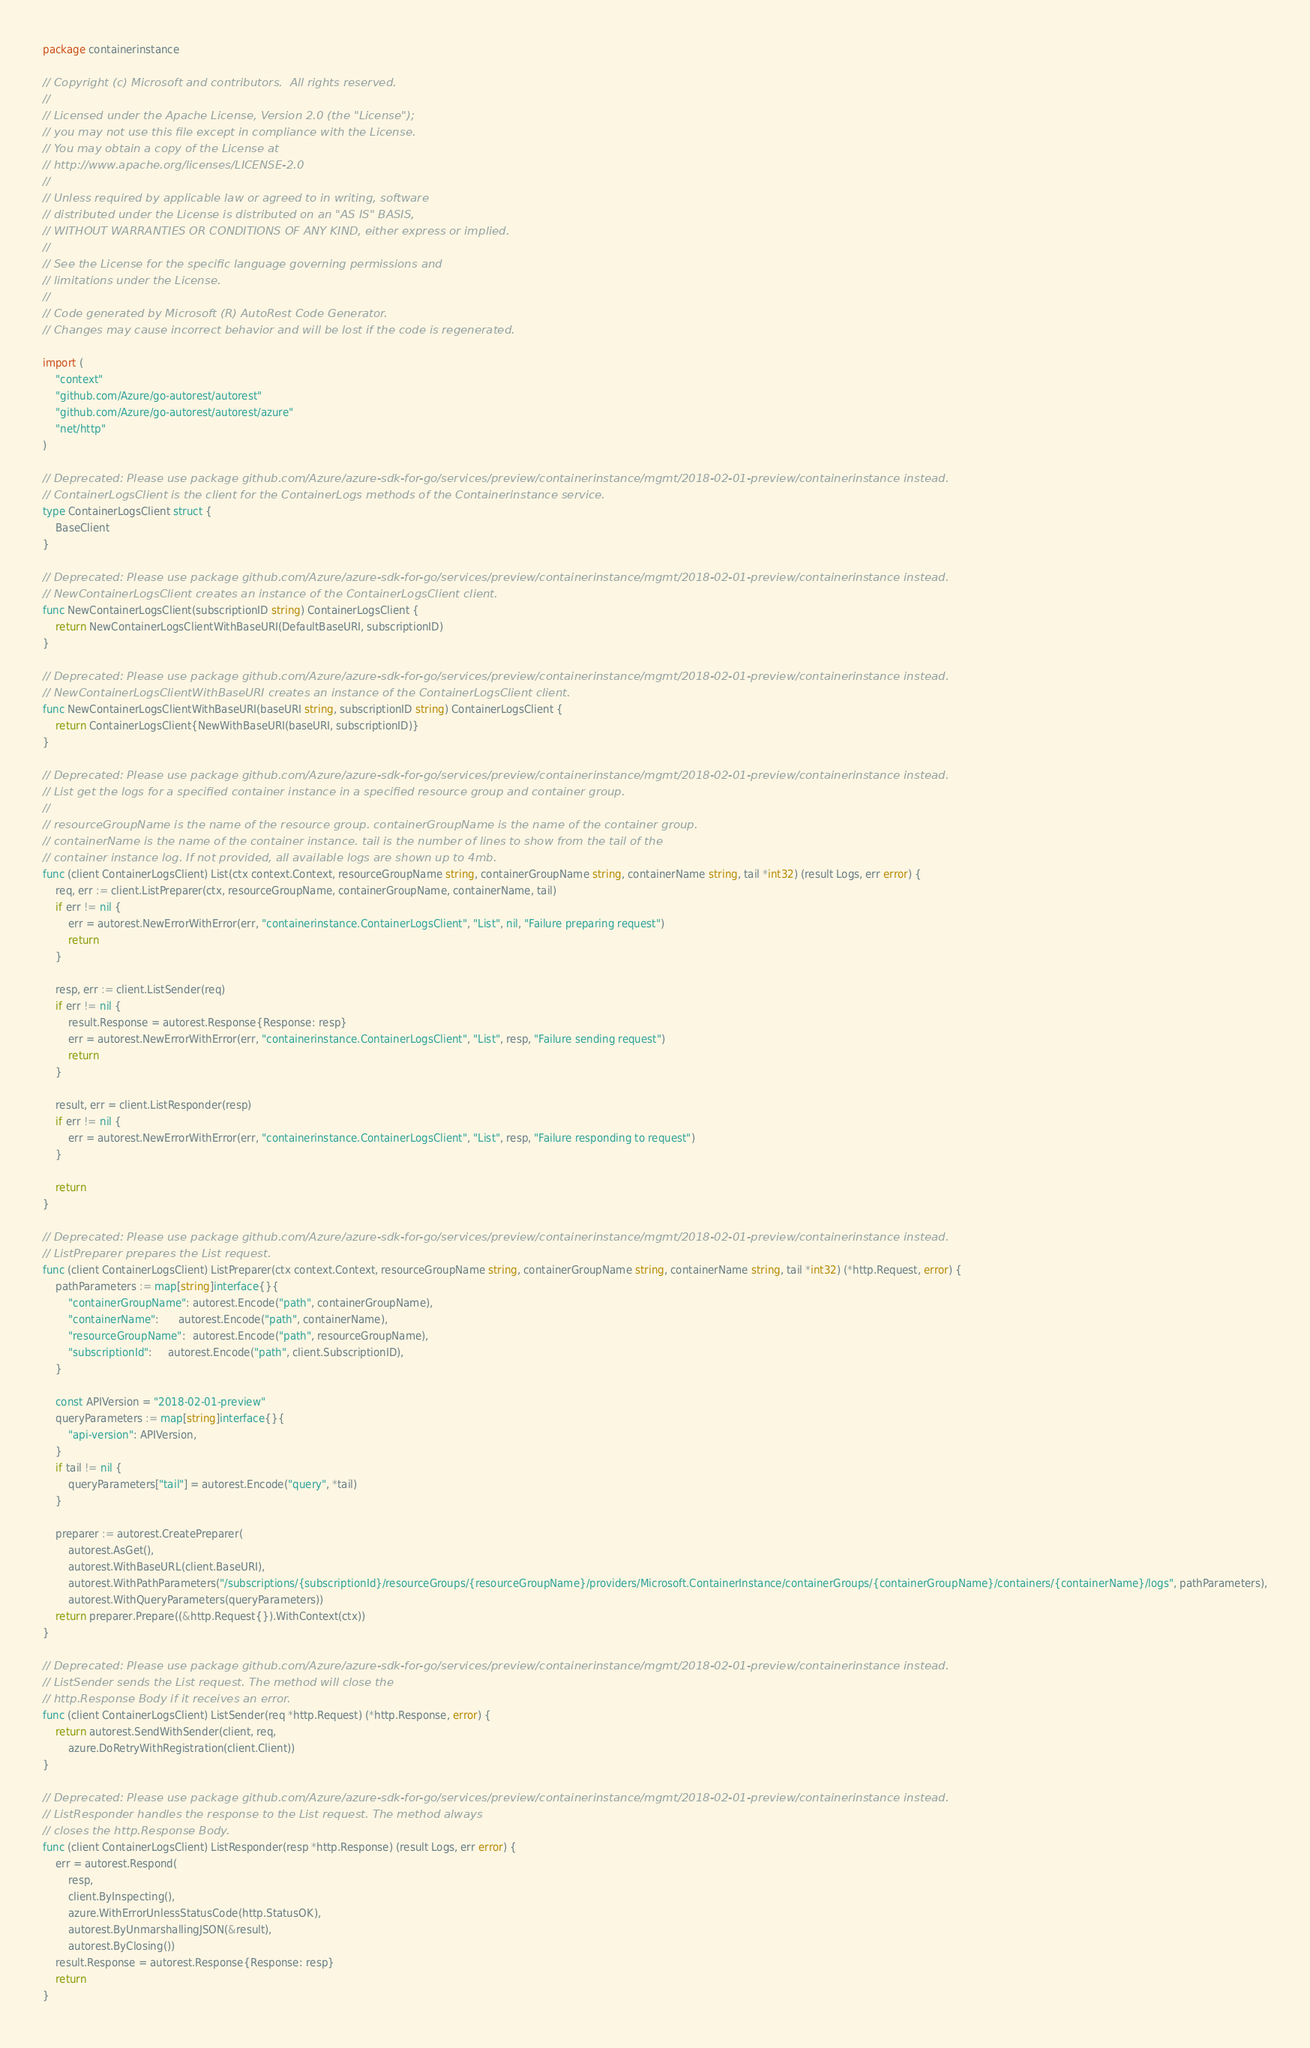<code> <loc_0><loc_0><loc_500><loc_500><_Go_>package containerinstance

// Copyright (c) Microsoft and contributors.  All rights reserved.
//
// Licensed under the Apache License, Version 2.0 (the "License");
// you may not use this file except in compliance with the License.
// You may obtain a copy of the License at
// http://www.apache.org/licenses/LICENSE-2.0
//
// Unless required by applicable law or agreed to in writing, software
// distributed under the License is distributed on an "AS IS" BASIS,
// WITHOUT WARRANTIES OR CONDITIONS OF ANY KIND, either express or implied.
//
// See the License for the specific language governing permissions and
// limitations under the License.
//
// Code generated by Microsoft (R) AutoRest Code Generator.
// Changes may cause incorrect behavior and will be lost if the code is regenerated.

import (
	"context"
	"github.com/Azure/go-autorest/autorest"
	"github.com/Azure/go-autorest/autorest/azure"
	"net/http"
)

// Deprecated: Please use package github.com/Azure/azure-sdk-for-go/services/preview/containerinstance/mgmt/2018-02-01-preview/containerinstance instead.
// ContainerLogsClient is the client for the ContainerLogs methods of the Containerinstance service.
type ContainerLogsClient struct {
	BaseClient
}

// Deprecated: Please use package github.com/Azure/azure-sdk-for-go/services/preview/containerinstance/mgmt/2018-02-01-preview/containerinstance instead.
// NewContainerLogsClient creates an instance of the ContainerLogsClient client.
func NewContainerLogsClient(subscriptionID string) ContainerLogsClient {
	return NewContainerLogsClientWithBaseURI(DefaultBaseURI, subscriptionID)
}

// Deprecated: Please use package github.com/Azure/azure-sdk-for-go/services/preview/containerinstance/mgmt/2018-02-01-preview/containerinstance instead.
// NewContainerLogsClientWithBaseURI creates an instance of the ContainerLogsClient client.
func NewContainerLogsClientWithBaseURI(baseURI string, subscriptionID string) ContainerLogsClient {
	return ContainerLogsClient{NewWithBaseURI(baseURI, subscriptionID)}
}

// Deprecated: Please use package github.com/Azure/azure-sdk-for-go/services/preview/containerinstance/mgmt/2018-02-01-preview/containerinstance instead.
// List get the logs for a specified container instance in a specified resource group and container group.
//
// resourceGroupName is the name of the resource group. containerGroupName is the name of the container group.
// containerName is the name of the container instance. tail is the number of lines to show from the tail of the
// container instance log. If not provided, all available logs are shown up to 4mb.
func (client ContainerLogsClient) List(ctx context.Context, resourceGroupName string, containerGroupName string, containerName string, tail *int32) (result Logs, err error) {
	req, err := client.ListPreparer(ctx, resourceGroupName, containerGroupName, containerName, tail)
	if err != nil {
		err = autorest.NewErrorWithError(err, "containerinstance.ContainerLogsClient", "List", nil, "Failure preparing request")
		return
	}

	resp, err := client.ListSender(req)
	if err != nil {
		result.Response = autorest.Response{Response: resp}
		err = autorest.NewErrorWithError(err, "containerinstance.ContainerLogsClient", "List", resp, "Failure sending request")
		return
	}

	result, err = client.ListResponder(resp)
	if err != nil {
		err = autorest.NewErrorWithError(err, "containerinstance.ContainerLogsClient", "List", resp, "Failure responding to request")
	}

	return
}

// Deprecated: Please use package github.com/Azure/azure-sdk-for-go/services/preview/containerinstance/mgmt/2018-02-01-preview/containerinstance instead.
// ListPreparer prepares the List request.
func (client ContainerLogsClient) ListPreparer(ctx context.Context, resourceGroupName string, containerGroupName string, containerName string, tail *int32) (*http.Request, error) {
	pathParameters := map[string]interface{}{
		"containerGroupName": autorest.Encode("path", containerGroupName),
		"containerName":      autorest.Encode("path", containerName),
		"resourceGroupName":  autorest.Encode("path", resourceGroupName),
		"subscriptionId":     autorest.Encode("path", client.SubscriptionID),
	}

	const APIVersion = "2018-02-01-preview"
	queryParameters := map[string]interface{}{
		"api-version": APIVersion,
	}
	if tail != nil {
		queryParameters["tail"] = autorest.Encode("query", *tail)
	}

	preparer := autorest.CreatePreparer(
		autorest.AsGet(),
		autorest.WithBaseURL(client.BaseURI),
		autorest.WithPathParameters("/subscriptions/{subscriptionId}/resourceGroups/{resourceGroupName}/providers/Microsoft.ContainerInstance/containerGroups/{containerGroupName}/containers/{containerName}/logs", pathParameters),
		autorest.WithQueryParameters(queryParameters))
	return preparer.Prepare((&http.Request{}).WithContext(ctx))
}

// Deprecated: Please use package github.com/Azure/azure-sdk-for-go/services/preview/containerinstance/mgmt/2018-02-01-preview/containerinstance instead.
// ListSender sends the List request. The method will close the
// http.Response Body if it receives an error.
func (client ContainerLogsClient) ListSender(req *http.Request) (*http.Response, error) {
	return autorest.SendWithSender(client, req,
		azure.DoRetryWithRegistration(client.Client))
}

// Deprecated: Please use package github.com/Azure/azure-sdk-for-go/services/preview/containerinstance/mgmt/2018-02-01-preview/containerinstance instead.
// ListResponder handles the response to the List request. The method always
// closes the http.Response Body.
func (client ContainerLogsClient) ListResponder(resp *http.Response) (result Logs, err error) {
	err = autorest.Respond(
		resp,
		client.ByInspecting(),
		azure.WithErrorUnlessStatusCode(http.StatusOK),
		autorest.ByUnmarshallingJSON(&result),
		autorest.ByClosing())
	result.Response = autorest.Response{Response: resp}
	return
}
</code> 